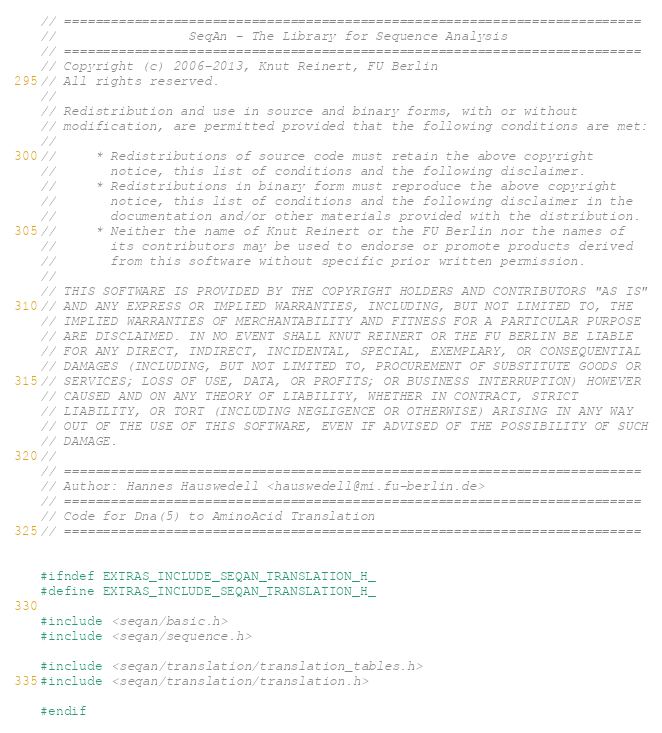Convert code to text. <code><loc_0><loc_0><loc_500><loc_500><_C_>// ==========================================================================
//                 SeqAn - The Library for Sequence Analysis
// ==========================================================================
// Copyright (c) 2006-2013, Knut Reinert, FU Berlin
// All rights reserved.
//
// Redistribution and use in source and binary forms, with or without
// modification, are permitted provided that the following conditions are met:
//
//     * Redistributions of source code must retain the above copyright
//       notice, this list of conditions and the following disclaimer.
//     * Redistributions in binary form must reproduce the above copyright
//       notice, this list of conditions and the following disclaimer in the
//       documentation and/or other materials provided with the distribution.
//     * Neither the name of Knut Reinert or the FU Berlin nor the names of
//       its contributors may be used to endorse or promote products derived
//       from this software without specific prior written permission.
//
// THIS SOFTWARE IS PROVIDED BY THE COPYRIGHT HOLDERS AND CONTRIBUTORS "AS IS"
// AND ANY EXPRESS OR IMPLIED WARRANTIES, INCLUDING, BUT NOT LIMITED TO, THE
// IMPLIED WARRANTIES OF MERCHANTABILITY AND FITNESS FOR A PARTICULAR PURPOSE
// ARE DISCLAIMED. IN NO EVENT SHALL KNUT REINERT OR THE FU BERLIN BE LIABLE
// FOR ANY DIRECT, INDIRECT, INCIDENTAL, SPECIAL, EXEMPLARY, OR CONSEQUENTIAL
// DAMAGES (INCLUDING, BUT NOT LIMITED TO, PROCUREMENT OF SUBSTITUTE GOODS OR
// SERVICES; LOSS OF USE, DATA, OR PROFITS; OR BUSINESS INTERRUPTION) HOWEVER
// CAUSED AND ON ANY THEORY OF LIABILITY, WHETHER IN CONTRACT, STRICT
// LIABILITY, OR TORT (INCLUDING NEGLIGENCE OR OTHERWISE) ARISING IN ANY WAY
// OUT OF THE USE OF THIS SOFTWARE, EVEN IF ADVISED OF THE POSSIBILITY OF SUCH
// DAMAGE.
//
// ==========================================================================
// Author: Hannes Hauswedell <hauswedell@mi.fu-berlin.de>
// ==========================================================================
// Code for Dna(5) to AminoAcid Translation
// ==========================================================================


#ifndef EXTRAS_INCLUDE_SEQAN_TRANSLATION_H_
#define EXTRAS_INCLUDE_SEQAN_TRANSLATION_H_

#include <seqan/basic.h>
#include <seqan/sequence.h>

#include <seqan/translation/translation_tables.h>
#include <seqan/translation/translation.h>

#endif
</code> 